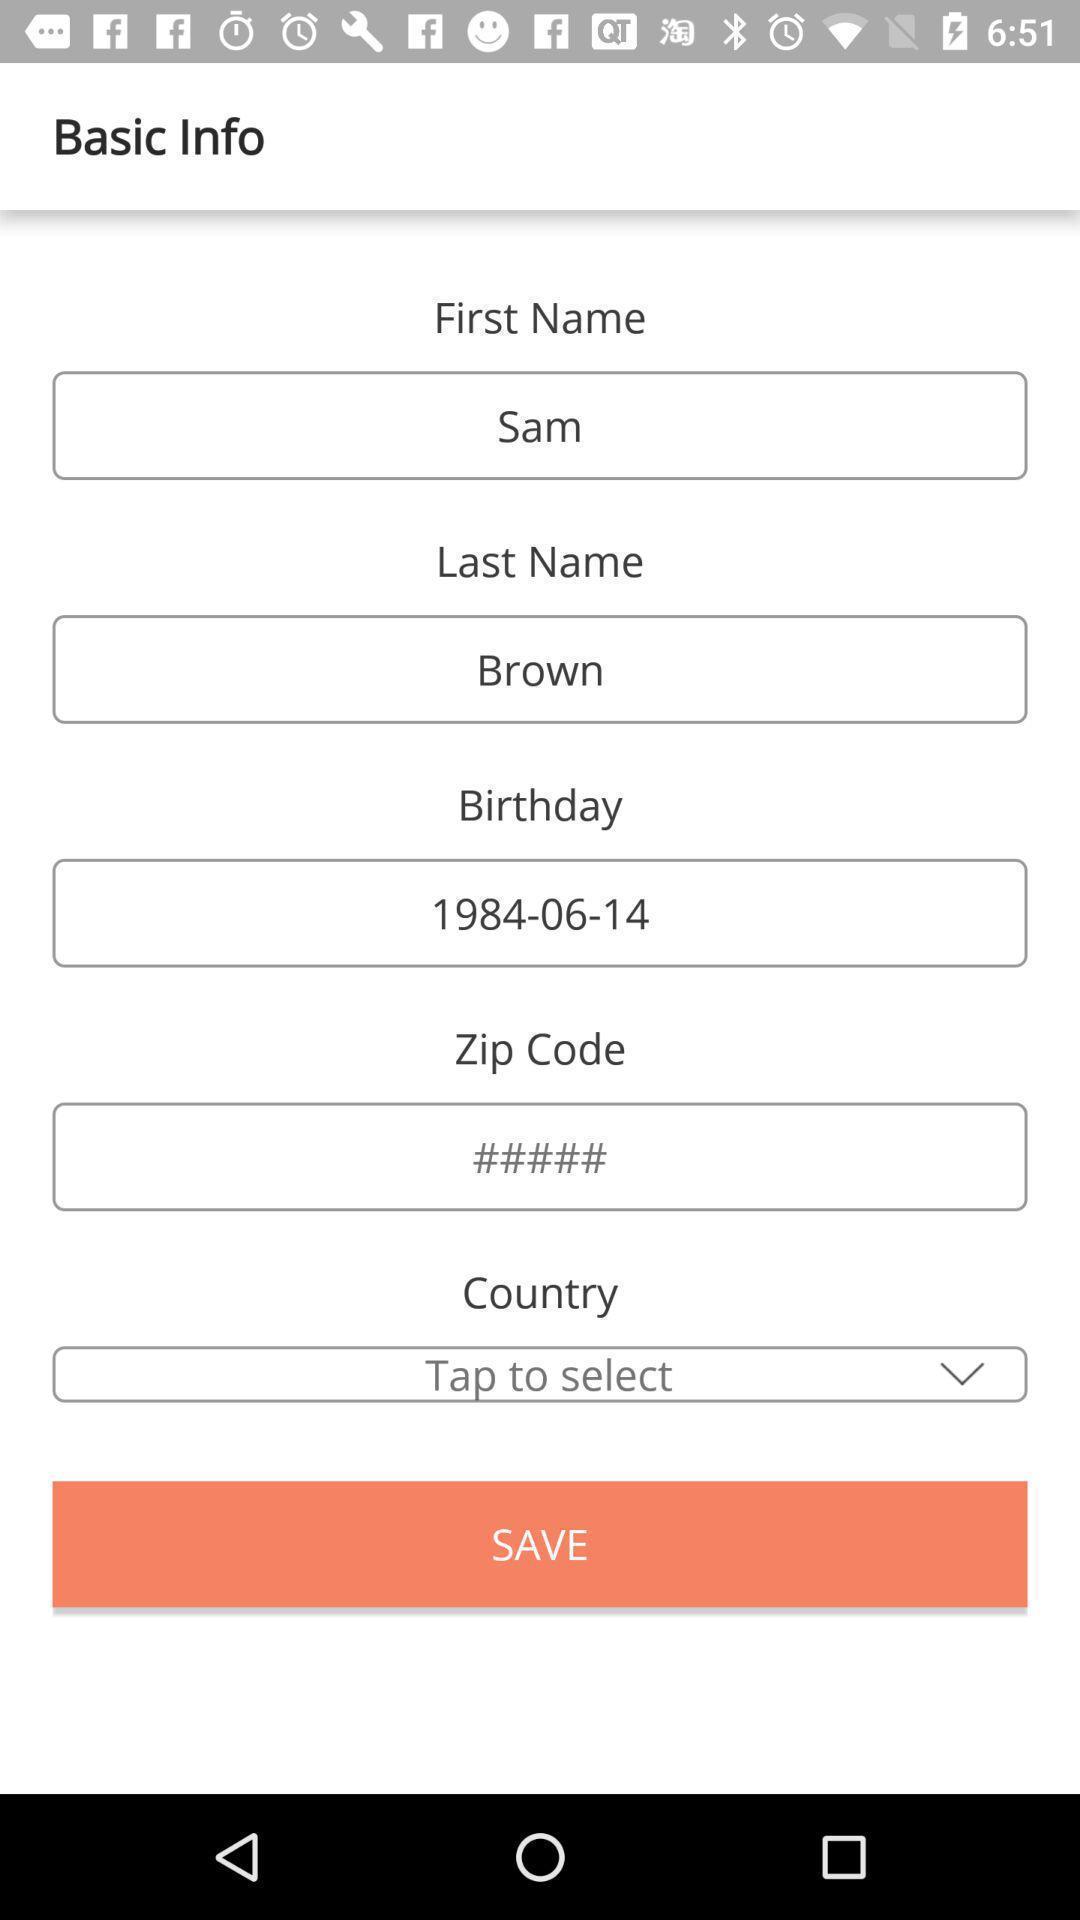Please provide a description for this image. Page displaying various details to fill. 